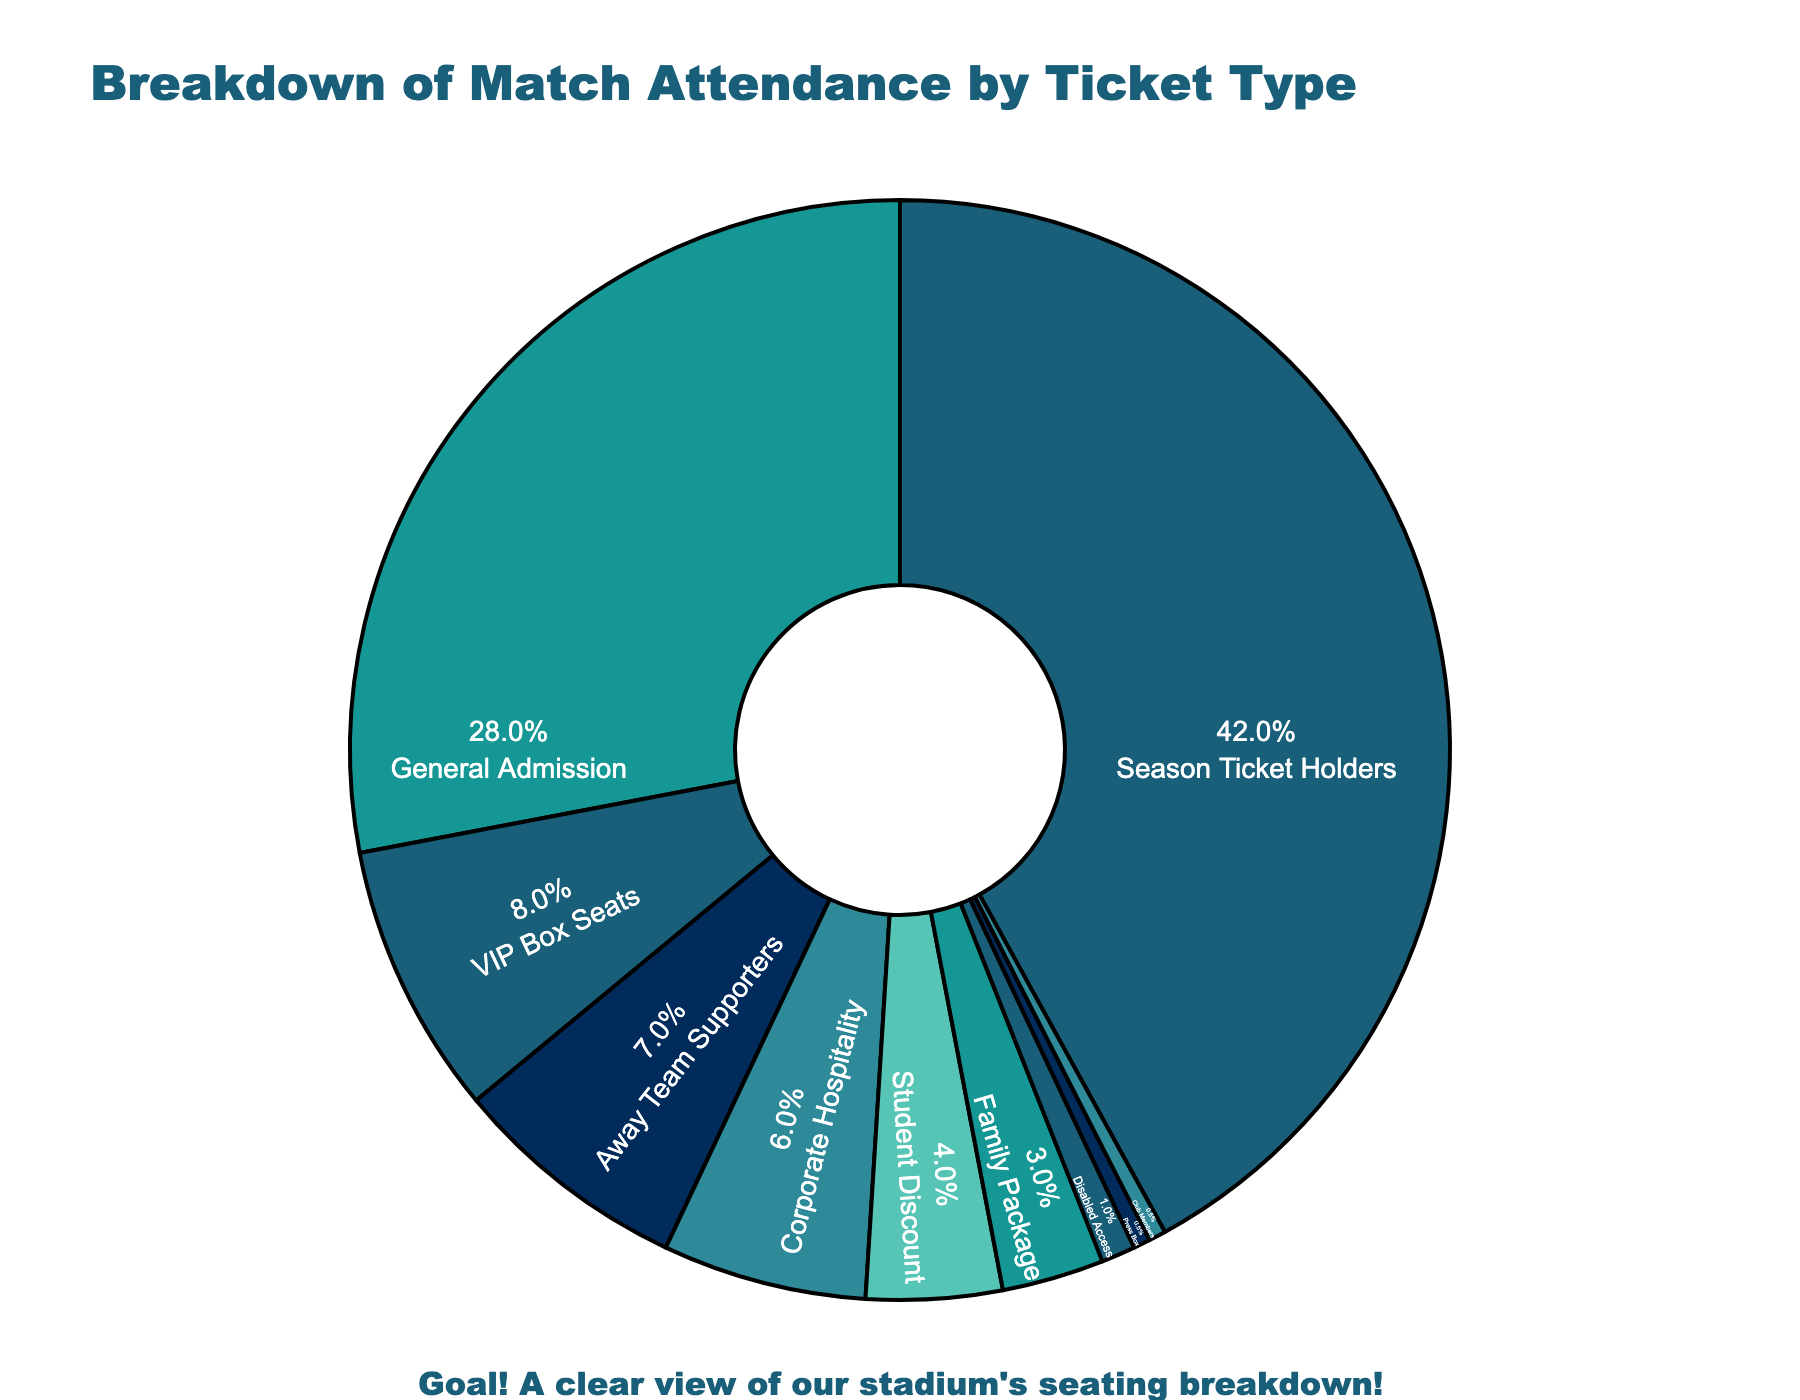Which ticket type has the highest percentage? From the chart, the ticket type with the largest segment is clearly identified. Season Ticket Holders comprise the largest percentage.
Answer: Season Ticket Holders What is the total percentage of General Admission and VIP Box Seats attendance? To find the total percentage, add the 28% for General Admission and the 8% for VIP Box Seats. 28% + 8% = 36%
Answer: 36% Are there more Corporate Hospitality or Away Team Supporters? By comparing the segments, Corporate Hospitality accounts for 6%, while Away Team Supporters account for 7%. Therefore, there are more Away Team Supporters.
Answer: Away Team Supporters What percentage of the total attendance is from Student Discount and Family Package combined? By adding the percentages together, 4% for Student Discount and 3% for Family Package, we get 4% + 3% = 7%.
Answer: 7% Which ticket type constitutes exactly 1% of the attendance? From the chart, Disabled Access is the ticket type with 1% attendance.
Answer: Disabled Access How much more is the attendance percentage of Season Ticket Holders compared to General Admission? Season Ticket Holders are 42%, while General Admission is 28%. The difference is 42% - 28% = 14%.
Answer: 14% Which two ticket types each make up 0.5% of the attendance? The chart shows that both Press Box and Club Members each have a segment that is 0.5% of the attendance.
Answer: Press Box and Club Members What is the combined percentage for all ticket types other than Season Ticket Holders and General Admission? Subtracting the percentages of Season Ticket Holders (42%) and General Admission (28%) from the total 100%, we use 100% - 42% - 28% = 30% for all other ticket types combined.
Answer: 30% Is the combined percentage of Student Discount, Family Package, and Disabled Access greater than the percentage of VIP Box Seats? Adding the percentages of Student Discount (4%), Family Package (3%), and Disabled Access (1%) gives 4% + 3% + 1% = 8%, which is equal to the percentage for VIP Box Seats (8%).
Answer: No Which ticket type occupies a visually distinct color compared to General Admission? Upon viewing the chart, General Admission is a distinct color from Corporate Hospitality.
Answer: Corporate Hospitality 